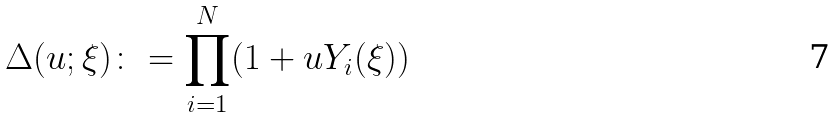<formula> <loc_0><loc_0><loc_500><loc_500>\Delta ( u ; \xi ) \colon = \prod _ { i = 1 } ^ { N } ( 1 + u Y _ { i } ( \xi ) )</formula> 